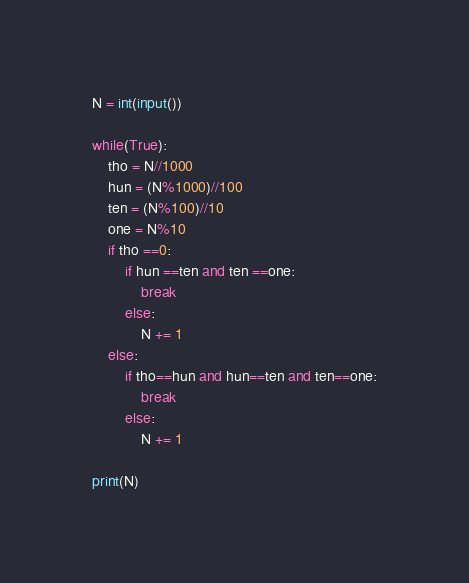Convert code to text. <code><loc_0><loc_0><loc_500><loc_500><_Python_>N = int(input())

while(True):
    tho = N//1000
    hun = (N%1000)//100
    ten = (N%100)//10
    one = N%10
    if tho ==0:
        if hun ==ten and ten ==one:
            break
        else:
            N += 1
    else:
        if tho==hun and hun==ten and ten==one:
            break
        else:
            N += 1

print(N)</code> 